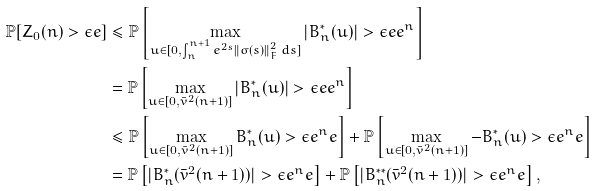<formula> <loc_0><loc_0><loc_500><loc_500>\mathbb { P } [ Z _ { 0 } ( n ) > \epsilon e ] & \leq \mathbb { P } \left [ \max _ { u \in [ 0 , \int _ { n } ^ { n + 1 } e ^ { 2 s } \| \sigma ( s ) \| ^ { 2 } _ { F } \, d s ] } \left | B ^ { \ast } _ { n } ( u ) \right | > \epsilon e e ^ { n } \right ] \\ & = \mathbb { P } \left [ \max _ { u \in [ 0 , \bar { v } ^ { 2 } ( n + 1 ) ] } \left | B ^ { \ast } _ { n } ( u ) \right | > \epsilon e e ^ { n } \right ] \\ & \leq \mathbb { P } \left [ \max _ { u \in [ 0 , \bar { v } ^ { 2 } ( n + 1 ) ] } B ^ { \ast } _ { n } ( u ) > \epsilon e ^ { n } e \right ] + \mathbb { P } \left [ \max _ { u \in [ 0 , \bar { v } ^ { 2 } ( n + 1 ) ] } - B ^ { \ast } _ { n } ( u ) > \epsilon e ^ { n } e \right ] \\ & = \mathbb { P } \left [ | B ^ { \ast } _ { n } ( \bar { v } ^ { 2 } ( n + 1 ) ) | > \epsilon e ^ { n } e \right ] + \mathbb { P } \left [ | B ^ { \ast \ast } _ { n } ( \bar { v } ^ { 2 } ( n + 1 ) ) | > \epsilon e ^ { n } e \right ] ,</formula> 